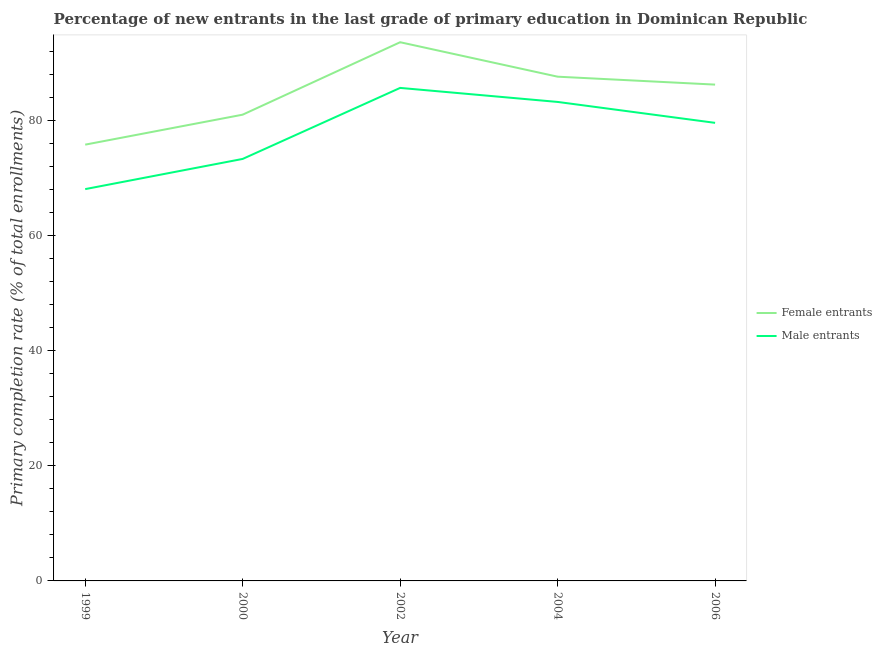Does the line corresponding to primary completion rate of male entrants intersect with the line corresponding to primary completion rate of female entrants?
Your answer should be compact. No. What is the primary completion rate of female entrants in 2004?
Give a very brief answer. 87.61. Across all years, what is the maximum primary completion rate of male entrants?
Ensure brevity in your answer.  85.66. Across all years, what is the minimum primary completion rate of male entrants?
Offer a very short reply. 68.07. In which year was the primary completion rate of female entrants maximum?
Make the answer very short. 2002. What is the total primary completion rate of female entrants in the graph?
Your answer should be compact. 424.25. What is the difference between the primary completion rate of female entrants in 2002 and that in 2006?
Your response must be concise. 7.36. What is the difference between the primary completion rate of female entrants in 1999 and the primary completion rate of male entrants in 2002?
Offer a terse response. -9.86. What is the average primary completion rate of male entrants per year?
Ensure brevity in your answer.  77.97. In the year 2006, what is the difference between the primary completion rate of male entrants and primary completion rate of female entrants?
Provide a short and direct response. -6.64. What is the ratio of the primary completion rate of male entrants in 2000 to that in 2004?
Provide a succinct answer. 0.88. Is the primary completion rate of female entrants in 1999 less than that in 2006?
Provide a short and direct response. Yes. What is the difference between the highest and the second highest primary completion rate of female entrants?
Provide a succinct answer. 5.99. What is the difference between the highest and the lowest primary completion rate of female entrants?
Provide a succinct answer. 17.79. How many years are there in the graph?
Offer a very short reply. 5. What is the difference between two consecutive major ticks on the Y-axis?
Your response must be concise. 20. Are the values on the major ticks of Y-axis written in scientific E-notation?
Provide a succinct answer. No. Where does the legend appear in the graph?
Keep it short and to the point. Center right. How are the legend labels stacked?
Give a very brief answer. Vertical. What is the title of the graph?
Your answer should be very brief. Percentage of new entrants in the last grade of primary education in Dominican Republic. What is the label or title of the Y-axis?
Provide a succinct answer. Primary completion rate (% of total enrollments). What is the Primary completion rate (% of total enrollments) of Female entrants in 1999?
Make the answer very short. 75.8. What is the Primary completion rate (% of total enrollments) of Male entrants in 1999?
Offer a very short reply. 68.07. What is the Primary completion rate (% of total enrollments) of Female entrants in 2000?
Provide a short and direct response. 81.01. What is the Primary completion rate (% of total enrollments) in Male entrants in 2000?
Your answer should be compact. 73.32. What is the Primary completion rate (% of total enrollments) in Female entrants in 2002?
Your answer should be compact. 93.6. What is the Primary completion rate (% of total enrollments) in Male entrants in 2002?
Offer a terse response. 85.66. What is the Primary completion rate (% of total enrollments) of Female entrants in 2004?
Ensure brevity in your answer.  87.61. What is the Primary completion rate (% of total enrollments) of Male entrants in 2004?
Provide a short and direct response. 83.22. What is the Primary completion rate (% of total enrollments) in Female entrants in 2006?
Your response must be concise. 86.23. What is the Primary completion rate (% of total enrollments) in Male entrants in 2006?
Offer a terse response. 79.59. Across all years, what is the maximum Primary completion rate (% of total enrollments) in Female entrants?
Provide a short and direct response. 93.6. Across all years, what is the maximum Primary completion rate (% of total enrollments) in Male entrants?
Make the answer very short. 85.66. Across all years, what is the minimum Primary completion rate (% of total enrollments) in Female entrants?
Provide a succinct answer. 75.8. Across all years, what is the minimum Primary completion rate (% of total enrollments) in Male entrants?
Your answer should be compact. 68.07. What is the total Primary completion rate (% of total enrollments) in Female entrants in the graph?
Offer a very short reply. 424.25. What is the total Primary completion rate (% of total enrollments) in Male entrants in the graph?
Keep it short and to the point. 389.86. What is the difference between the Primary completion rate (% of total enrollments) in Female entrants in 1999 and that in 2000?
Offer a terse response. -5.21. What is the difference between the Primary completion rate (% of total enrollments) of Male entrants in 1999 and that in 2000?
Keep it short and to the point. -5.25. What is the difference between the Primary completion rate (% of total enrollments) of Female entrants in 1999 and that in 2002?
Your answer should be compact. -17.79. What is the difference between the Primary completion rate (% of total enrollments) in Male entrants in 1999 and that in 2002?
Offer a very short reply. -17.58. What is the difference between the Primary completion rate (% of total enrollments) of Female entrants in 1999 and that in 2004?
Give a very brief answer. -11.81. What is the difference between the Primary completion rate (% of total enrollments) of Male entrants in 1999 and that in 2004?
Provide a succinct answer. -15.15. What is the difference between the Primary completion rate (% of total enrollments) in Female entrants in 1999 and that in 2006?
Your answer should be very brief. -10.43. What is the difference between the Primary completion rate (% of total enrollments) of Male entrants in 1999 and that in 2006?
Offer a terse response. -11.51. What is the difference between the Primary completion rate (% of total enrollments) of Female entrants in 2000 and that in 2002?
Your answer should be very brief. -12.59. What is the difference between the Primary completion rate (% of total enrollments) in Male entrants in 2000 and that in 2002?
Offer a terse response. -12.34. What is the difference between the Primary completion rate (% of total enrollments) in Female entrants in 2000 and that in 2004?
Keep it short and to the point. -6.6. What is the difference between the Primary completion rate (% of total enrollments) of Male entrants in 2000 and that in 2004?
Ensure brevity in your answer.  -9.9. What is the difference between the Primary completion rate (% of total enrollments) in Female entrants in 2000 and that in 2006?
Make the answer very short. -5.22. What is the difference between the Primary completion rate (% of total enrollments) in Male entrants in 2000 and that in 2006?
Give a very brief answer. -6.27. What is the difference between the Primary completion rate (% of total enrollments) in Female entrants in 2002 and that in 2004?
Your response must be concise. 5.99. What is the difference between the Primary completion rate (% of total enrollments) in Male entrants in 2002 and that in 2004?
Ensure brevity in your answer.  2.44. What is the difference between the Primary completion rate (% of total enrollments) in Female entrants in 2002 and that in 2006?
Your answer should be compact. 7.36. What is the difference between the Primary completion rate (% of total enrollments) of Male entrants in 2002 and that in 2006?
Your answer should be compact. 6.07. What is the difference between the Primary completion rate (% of total enrollments) of Female entrants in 2004 and that in 2006?
Your answer should be compact. 1.38. What is the difference between the Primary completion rate (% of total enrollments) of Male entrants in 2004 and that in 2006?
Your answer should be very brief. 3.63. What is the difference between the Primary completion rate (% of total enrollments) of Female entrants in 1999 and the Primary completion rate (% of total enrollments) of Male entrants in 2000?
Provide a succinct answer. 2.48. What is the difference between the Primary completion rate (% of total enrollments) in Female entrants in 1999 and the Primary completion rate (% of total enrollments) in Male entrants in 2002?
Give a very brief answer. -9.86. What is the difference between the Primary completion rate (% of total enrollments) of Female entrants in 1999 and the Primary completion rate (% of total enrollments) of Male entrants in 2004?
Your response must be concise. -7.42. What is the difference between the Primary completion rate (% of total enrollments) in Female entrants in 1999 and the Primary completion rate (% of total enrollments) in Male entrants in 2006?
Your answer should be very brief. -3.79. What is the difference between the Primary completion rate (% of total enrollments) of Female entrants in 2000 and the Primary completion rate (% of total enrollments) of Male entrants in 2002?
Ensure brevity in your answer.  -4.65. What is the difference between the Primary completion rate (% of total enrollments) in Female entrants in 2000 and the Primary completion rate (% of total enrollments) in Male entrants in 2004?
Your answer should be compact. -2.21. What is the difference between the Primary completion rate (% of total enrollments) in Female entrants in 2000 and the Primary completion rate (% of total enrollments) in Male entrants in 2006?
Ensure brevity in your answer.  1.42. What is the difference between the Primary completion rate (% of total enrollments) in Female entrants in 2002 and the Primary completion rate (% of total enrollments) in Male entrants in 2004?
Your response must be concise. 10.38. What is the difference between the Primary completion rate (% of total enrollments) in Female entrants in 2002 and the Primary completion rate (% of total enrollments) in Male entrants in 2006?
Your response must be concise. 14.01. What is the difference between the Primary completion rate (% of total enrollments) in Female entrants in 2004 and the Primary completion rate (% of total enrollments) in Male entrants in 2006?
Offer a terse response. 8.02. What is the average Primary completion rate (% of total enrollments) in Female entrants per year?
Keep it short and to the point. 84.85. What is the average Primary completion rate (% of total enrollments) in Male entrants per year?
Provide a short and direct response. 77.97. In the year 1999, what is the difference between the Primary completion rate (% of total enrollments) of Female entrants and Primary completion rate (% of total enrollments) of Male entrants?
Offer a terse response. 7.73. In the year 2000, what is the difference between the Primary completion rate (% of total enrollments) of Female entrants and Primary completion rate (% of total enrollments) of Male entrants?
Give a very brief answer. 7.69. In the year 2002, what is the difference between the Primary completion rate (% of total enrollments) of Female entrants and Primary completion rate (% of total enrollments) of Male entrants?
Your response must be concise. 7.94. In the year 2004, what is the difference between the Primary completion rate (% of total enrollments) in Female entrants and Primary completion rate (% of total enrollments) in Male entrants?
Give a very brief answer. 4.39. In the year 2006, what is the difference between the Primary completion rate (% of total enrollments) of Female entrants and Primary completion rate (% of total enrollments) of Male entrants?
Your answer should be compact. 6.64. What is the ratio of the Primary completion rate (% of total enrollments) in Female entrants in 1999 to that in 2000?
Keep it short and to the point. 0.94. What is the ratio of the Primary completion rate (% of total enrollments) of Male entrants in 1999 to that in 2000?
Ensure brevity in your answer.  0.93. What is the ratio of the Primary completion rate (% of total enrollments) of Female entrants in 1999 to that in 2002?
Give a very brief answer. 0.81. What is the ratio of the Primary completion rate (% of total enrollments) in Male entrants in 1999 to that in 2002?
Your answer should be compact. 0.79. What is the ratio of the Primary completion rate (% of total enrollments) of Female entrants in 1999 to that in 2004?
Provide a short and direct response. 0.87. What is the ratio of the Primary completion rate (% of total enrollments) in Male entrants in 1999 to that in 2004?
Give a very brief answer. 0.82. What is the ratio of the Primary completion rate (% of total enrollments) of Female entrants in 1999 to that in 2006?
Offer a very short reply. 0.88. What is the ratio of the Primary completion rate (% of total enrollments) in Male entrants in 1999 to that in 2006?
Your response must be concise. 0.86. What is the ratio of the Primary completion rate (% of total enrollments) of Female entrants in 2000 to that in 2002?
Your answer should be compact. 0.87. What is the ratio of the Primary completion rate (% of total enrollments) in Male entrants in 2000 to that in 2002?
Make the answer very short. 0.86. What is the ratio of the Primary completion rate (% of total enrollments) in Female entrants in 2000 to that in 2004?
Provide a short and direct response. 0.92. What is the ratio of the Primary completion rate (% of total enrollments) in Male entrants in 2000 to that in 2004?
Give a very brief answer. 0.88. What is the ratio of the Primary completion rate (% of total enrollments) in Female entrants in 2000 to that in 2006?
Your answer should be compact. 0.94. What is the ratio of the Primary completion rate (% of total enrollments) of Male entrants in 2000 to that in 2006?
Offer a very short reply. 0.92. What is the ratio of the Primary completion rate (% of total enrollments) in Female entrants in 2002 to that in 2004?
Make the answer very short. 1.07. What is the ratio of the Primary completion rate (% of total enrollments) of Male entrants in 2002 to that in 2004?
Give a very brief answer. 1.03. What is the ratio of the Primary completion rate (% of total enrollments) in Female entrants in 2002 to that in 2006?
Your answer should be very brief. 1.09. What is the ratio of the Primary completion rate (% of total enrollments) in Male entrants in 2002 to that in 2006?
Your answer should be compact. 1.08. What is the ratio of the Primary completion rate (% of total enrollments) of Female entrants in 2004 to that in 2006?
Keep it short and to the point. 1.02. What is the ratio of the Primary completion rate (% of total enrollments) of Male entrants in 2004 to that in 2006?
Your answer should be very brief. 1.05. What is the difference between the highest and the second highest Primary completion rate (% of total enrollments) in Female entrants?
Your answer should be compact. 5.99. What is the difference between the highest and the second highest Primary completion rate (% of total enrollments) in Male entrants?
Offer a very short reply. 2.44. What is the difference between the highest and the lowest Primary completion rate (% of total enrollments) of Female entrants?
Offer a very short reply. 17.79. What is the difference between the highest and the lowest Primary completion rate (% of total enrollments) in Male entrants?
Your answer should be very brief. 17.58. 